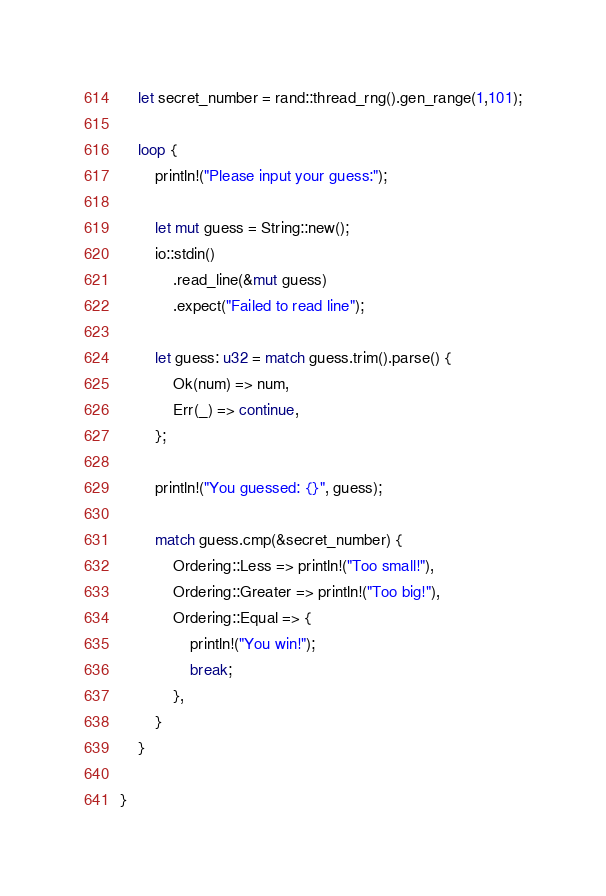<code> <loc_0><loc_0><loc_500><loc_500><_Rust_>    let secret_number = rand::thread_rng().gen_range(1,101);

    loop {
        println!("Please input your guess:");

        let mut guess = String::new();
        io::stdin()
            .read_line(&mut guess)
            .expect("Failed to read line");

        let guess: u32 = match guess.trim().parse() {
            Ok(num) => num,
            Err(_) => continue,
        };
        
        println!("You guessed: {}", guess);

        match guess.cmp(&secret_number) {
            Ordering::Less => println!("Too small!"),
            Ordering::Greater => println!("Too big!"),
            Ordering::Equal => {
                println!("You win!");
                break;
            },
        }
    }
    
}
</code> 